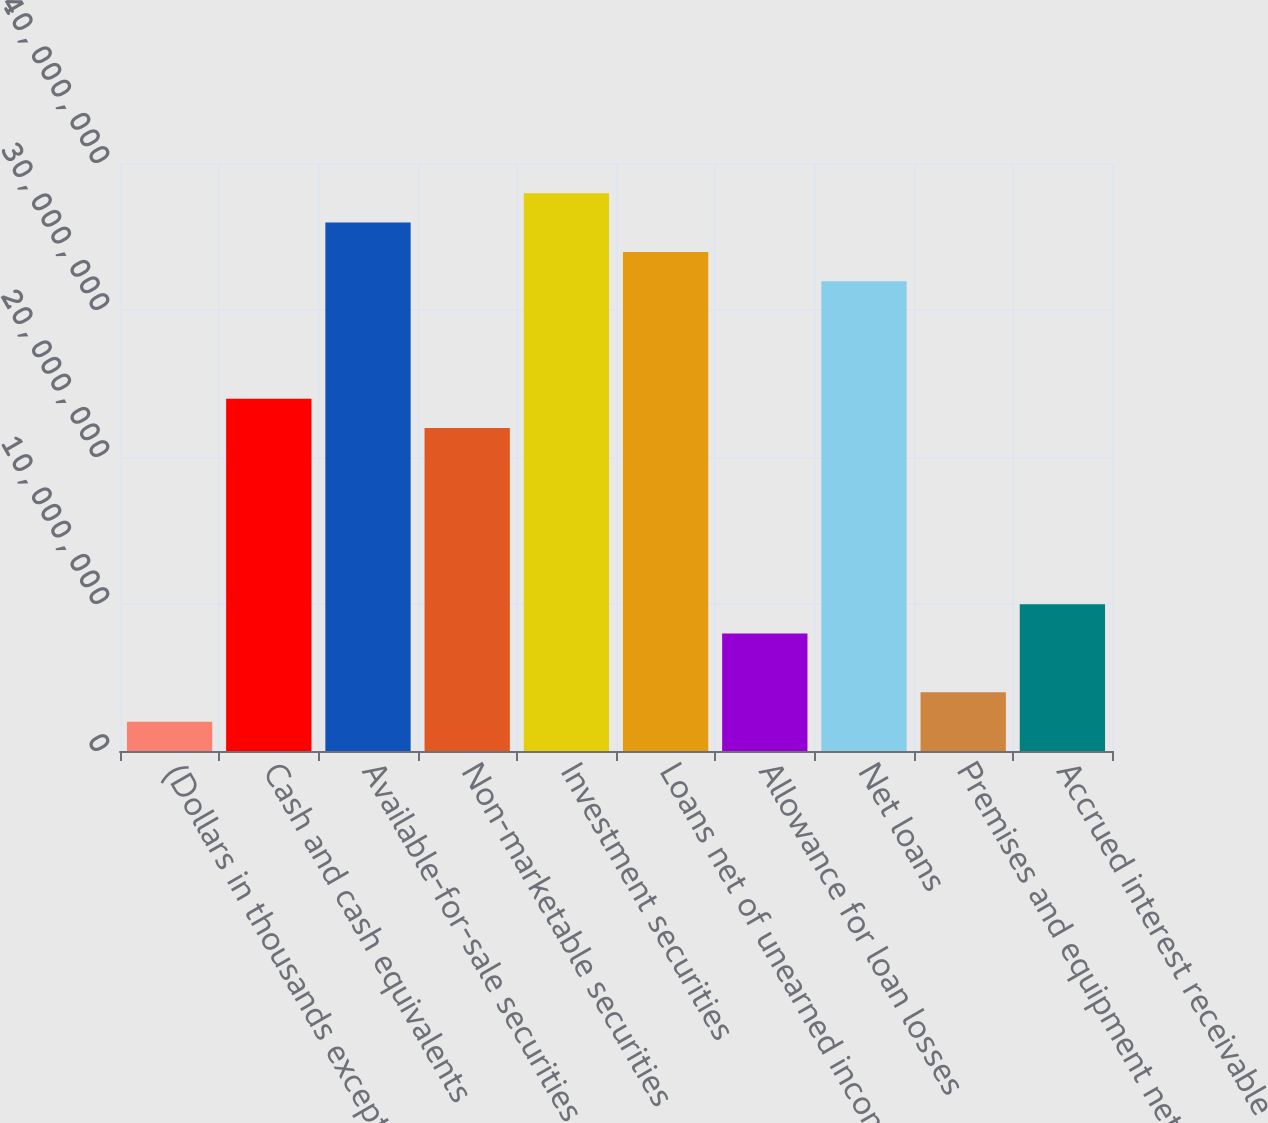<chart> <loc_0><loc_0><loc_500><loc_500><bar_chart><fcel>(Dollars in thousands except<fcel>Cash and cash equivalents<fcel>Available-for-sale securities<fcel>Non-marketable securities<fcel>Investment securities<fcel>Loans net of unearned income<fcel>Allowance for loan losses<fcel>Net loans<fcel>Premises and equipment net of<fcel>Accrued interest receivable<nl><fcel>1.99693e+06<fcel>2.39627e+07<fcel>3.5944e+07<fcel>2.19658e+07<fcel>3.79409e+07<fcel>3.39471e+07<fcel>7.98758e+06<fcel>3.19502e+07<fcel>3.99381e+06<fcel>9.98447e+06<nl></chart> 